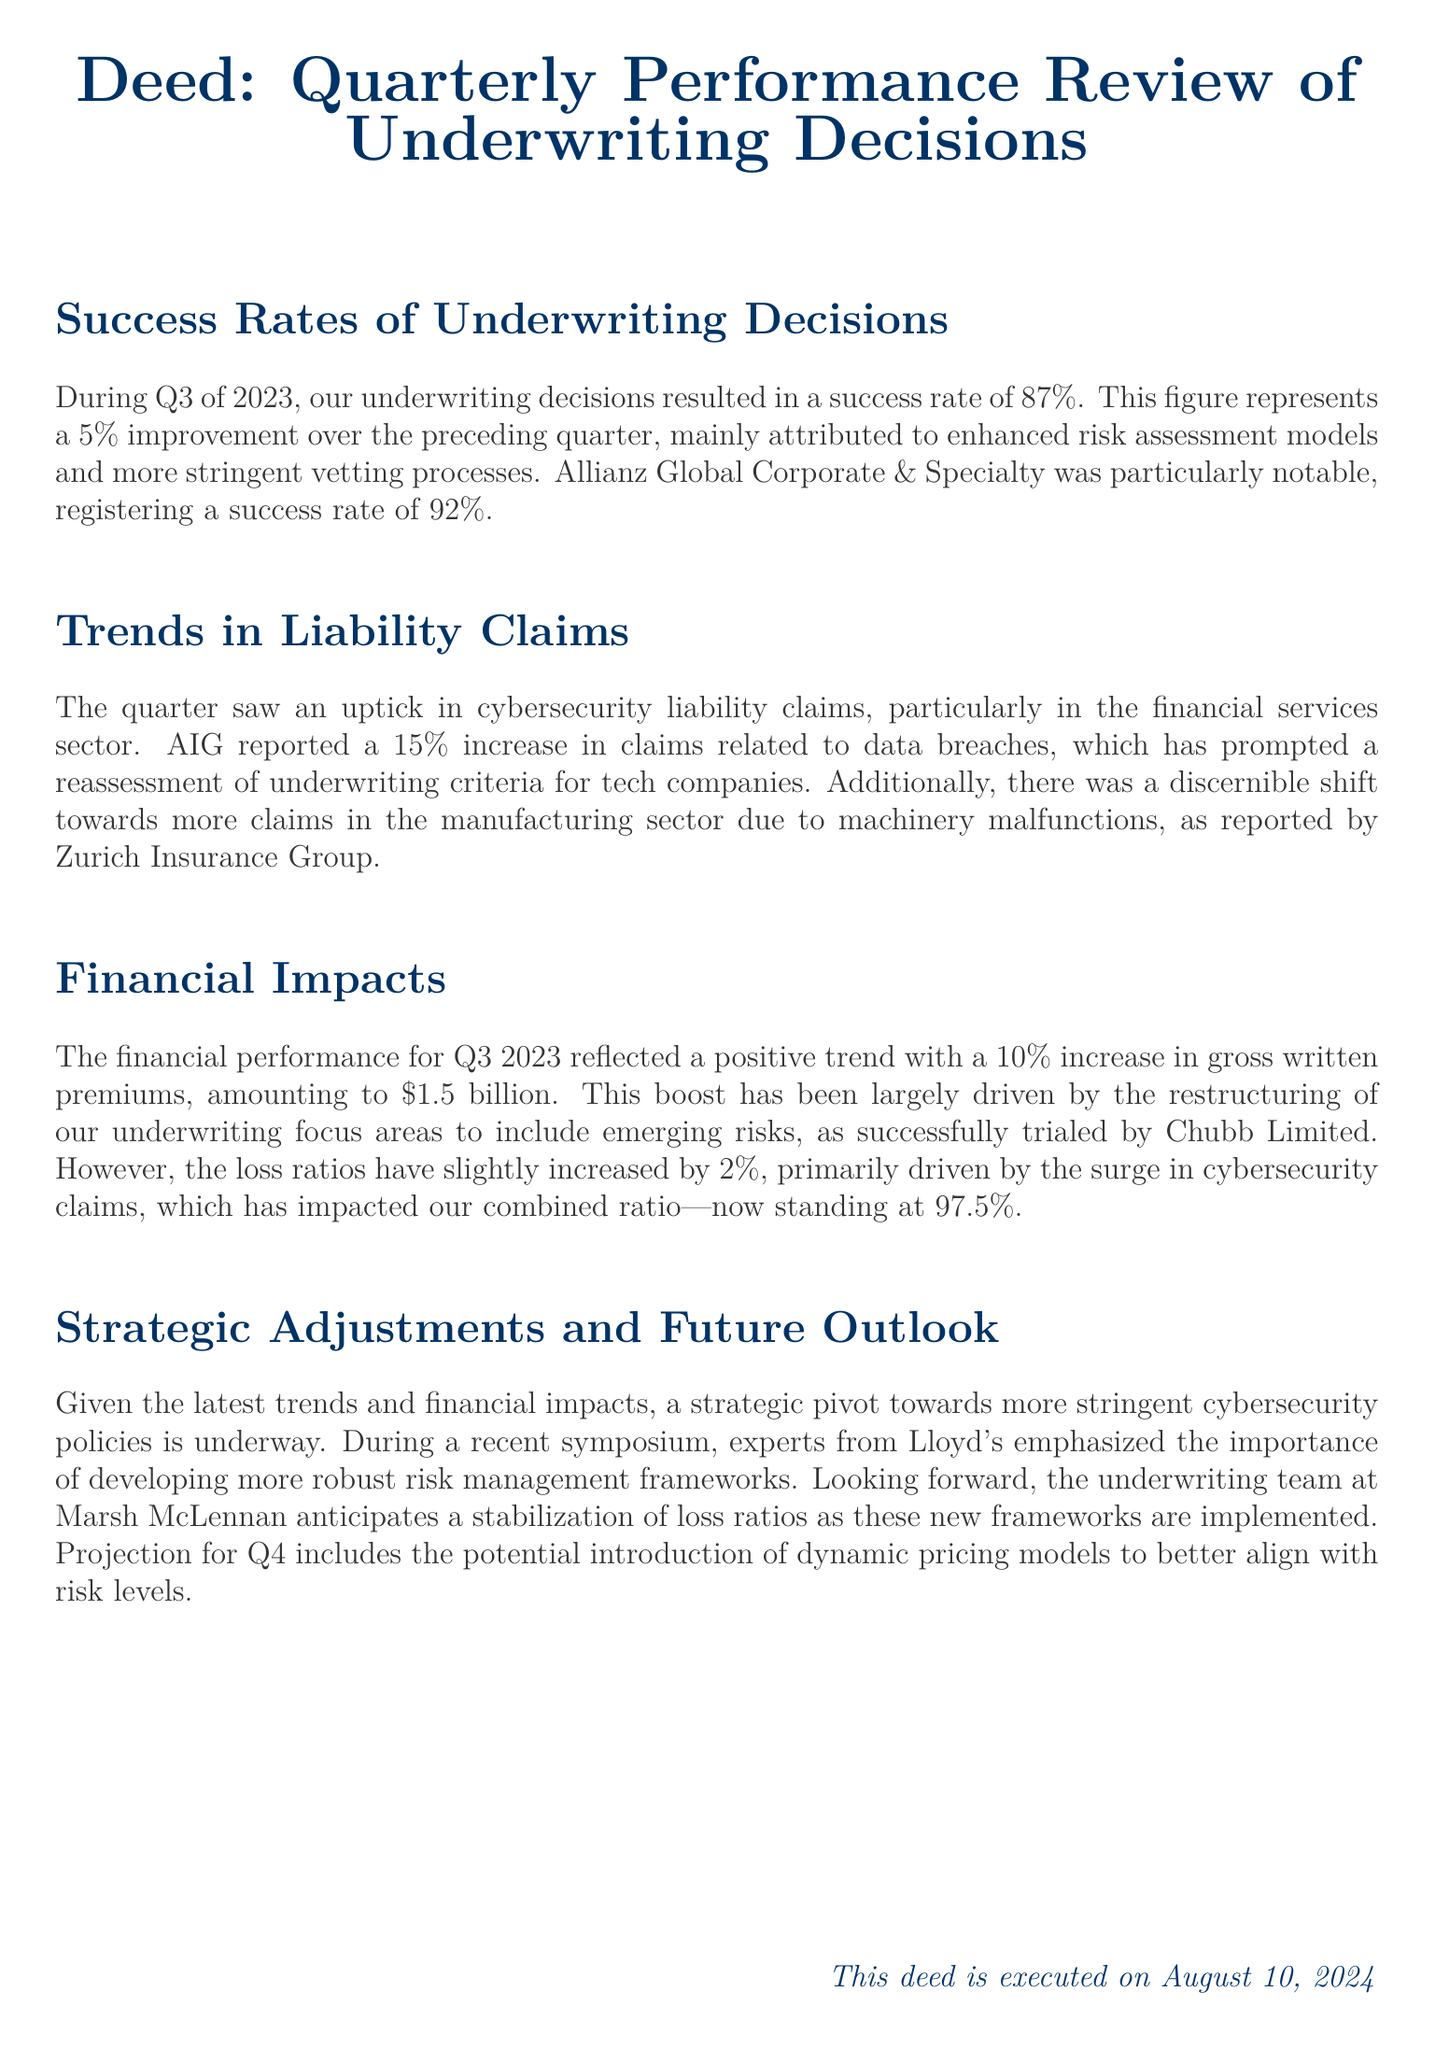What was the success rate for Q3 of 2023? The success rate during Q3 of 2023 was specifically mentioned as 87%.
Answer: 87% What was the increase in gross written premiums for Q3 2023? A 10% increase in gross written premiums was stated for Q3 2023.
Answer: 10% Which company had a notable success rate of 92%? Allianz Global Corporate & Specialty was highlighted for having a success rate of 92%.
Answer: Allianz Global Corporate & Specialty What sector experienced a 15% increase in claims? The financial services sector experienced the 15% increase in claims related to data breaches.
Answer: Financial services sector What is the current combined ratio mentioned in the document? The combined ratio is reported as 97.5%.
Answer: 97.5% What are the new frameworks emphasized by experts from Lloyd's? More robust risk management frameworks are being emphasized by experts from Lloyd's.
Answer: More robust risk management frameworks What prompted a reassessment of underwriting criteria for tech companies? The 15% increase in claims related to data breaches prompted the reassessment.
Answer: 15% increase in claims related to data breaches What type of pricing models might be introduced in Q4? The document suggests the potential introduction of dynamic pricing models for Q4.
Answer: Dynamic pricing models What was the net effect on loss ratios in Q3 2023? The loss ratios increased slightly by 2%.
Answer: 2% 